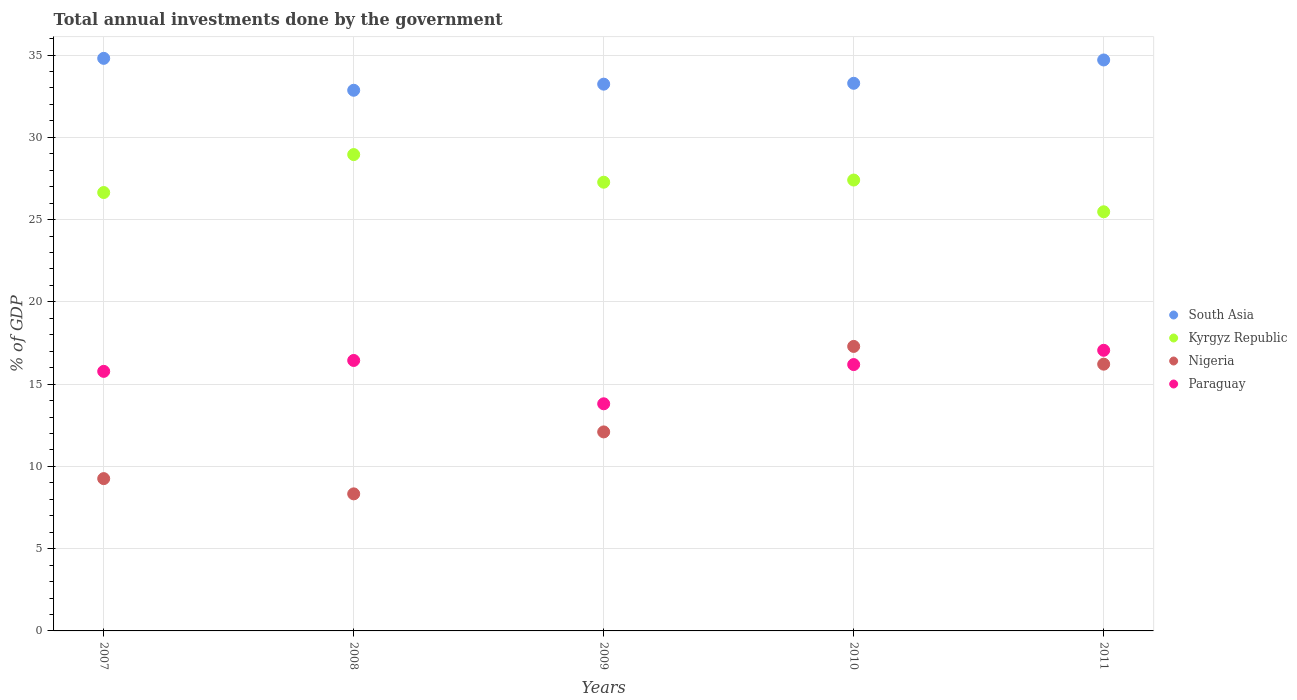How many different coloured dotlines are there?
Offer a terse response. 4. What is the total annual investments done by the government in Kyrgyz Republic in 2009?
Give a very brief answer. 27.27. Across all years, what is the maximum total annual investments done by the government in South Asia?
Provide a succinct answer. 34.8. Across all years, what is the minimum total annual investments done by the government in Paraguay?
Your response must be concise. 13.8. In which year was the total annual investments done by the government in Kyrgyz Republic maximum?
Your answer should be compact. 2008. In which year was the total annual investments done by the government in Nigeria minimum?
Offer a very short reply. 2008. What is the total total annual investments done by the government in Nigeria in the graph?
Your answer should be very brief. 63.18. What is the difference between the total annual investments done by the government in South Asia in 2009 and that in 2010?
Give a very brief answer. -0.05. What is the difference between the total annual investments done by the government in Nigeria in 2007 and the total annual investments done by the government in Kyrgyz Republic in 2009?
Offer a terse response. -18.01. What is the average total annual investments done by the government in Paraguay per year?
Offer a terse response. 15.85. In the year 2009, what is the difference between the total annual investments done by the government in South Asia and total annual investments done by the government in Nigeria?
Your answer should be very brief. 21.13. What is the ratio of the total annual investments done by the government in Kyrgyz Republic in 2008 to that in 2010?
Provide a succinct answer. 1.06. Is the total annual investments done by the government in South Asia in 2007 less than that in 2009?
Provide a short and direct response. No. Is the difference between the total annual investments done by the government in South Asia in 2007 and 2009 greater than the difference between the total annual investments done by the government in Nigeria in 2007 and 2009?
Ensure brevity in your answer.  Yes. What is the difference between the highest and the second highest total annual investments done by the government in South Asia?
Provide a short and direct response. 0.1. What is the difference between the highest and the lowest total annual investments done by the government in Nigeria?
Your answer should be compact. 8.96. In how many years, is the total annual investments done by the government in Paraguay greater than the average total annual investments done by the government in Paraguay taken over all years?
Offer a very short reply. 3. Is it the case that in every year, the sum of the total annual investments done by the government in Nigeria and total annual investments done by the government in Kyrgyz Republic  is greater than the total annual investments done by the government in Paraguay?
Provide a succinct answer. Yes. Does the total annual investments done by the government in South Asia monotonically increase over the years?
Ensure brevity in your answer.  No. How many dotlines are there?
Provide a short and direct response. 4. What is the difference between two consecutive major ticks on the Y-axis?
Make the answer very short. 5. Does the graph contain grids?
Offer a very short reply. Yes. How many legend labels are there?
Your response must be concise. 4. What is the title of the graph?
Your answer should be very brief. Total annual investments done by the government. What is the label or title of the X-axis?
Your answer should be compact. Years. What is the label or title of the Y-axis?
Offer a very short reply. % of GDP. What is the % of GDP of South Asia in 2007?
Offer a very short reply. 34.8. What is the % of GDP in Kyrgyz Republic in 2007?
Give a very brief answer. 26.64. What is the % of GDP of Nigeria in 2007?
Provide a short and direct response. 9.26. What is the % of GDP in Paraguay in 2007?
Provide a succinct answer. 15.77. What is the % of GDP in South Asia in 2008?
Provide a succinct answer. 32.86. What is the % of GDP of Kyrgyz Republic in 2008?
Make the answer very short. 28.95. What is the % of GDP in Nigeria in 2008?
Provide a short and direct response. 8.33. What is the % of GDP in Paraguay in 2008?
Your response must be concise. 16.44. What is the % of GDP in South Asia in 2009?
Provide a succinct answer. 33.23. What is the % of GDP of Kyrgyz Republic in 2009?
Keep it short and to the point. 27.27. What is the % of GDP in Nigeria in 2009?
Your answer should be very brief. 12.09. What is the % of GDP in Paraguay in 2009?
Keep it short and to the point. 13.8. What is the % of GDP of South Asia in 2010?
Provide a short and direct response. 33.28. What is the % of GDP in Kyrgyz Republic in 2010?
Offer a very short reply. 27.4. What is the % of GDP of Nigeria in 2010?
Your answer should be compact. 17.29. What is the % of GDP of Paraguay in 2010?
Give a very brief answer. 16.19. What is the % of GDP in South Asia in 2011?
Make the answer very short. 34.7. What is the % of GDP of Kyrgyz Republic in 2011?
Provide a short and direct response. 25.47. What is the % of GDP in Nigeria in 2011?
Provide a short and direct response. 16.21. What is the % of GDP of Paraguay in 2011?
Give a very brief answer. 17.05. Across all years, what is the maximum % of GDP of South Asia?
Your answer should be very brief. 34.8. Across all years, what is the maximum % of GDP in Kyrgyz Republic?
Provide a short and direct response. 28.95. Across all years, what is the maximum % of GDP of Nigeria?
Your answer should be compact. 17.29. Across all years, what is the maximum % of GDP in Paraguay?
Keep it short and to the point. 17.05. Across all years, what is the minimum % of GDP in South Asia?
Your answer should be compact. 32.86. Across all years, what is the minimum % of GDP of Kyrgyz Republic?
Your response must be concise. 25.47. Across all years, what is the minimum % of GDP of Nigeria?
Ensure brevity in your answer.  8.33. Across all years, what is the minimum % of GDP of Paraguay?
Offer a terse response. 13.8. What is the total % of GDP in South Asia in the graph?
Offer a very short reply. 168.87. What is the total % of GDP of Kyrgyz Republic in the graph?
Your answer should be very brief. 135.74. What is the total % of GDP in Nigeria in the graph?
Offer a terse response. 63.18. What is the total % of GDP in Paraguay in the graph?
Your answer should be compact. 79.26. What is the difference between the % of GDP in South Asia in 2007 and that in 2008?
Your response must be concise. 1.94. What is the difference between the % of GDP in Kyrgyz Republic in 2007 and that in 2008?
Give a very brief answer. -2.31. What is the difference between the % of GDP in Nigeria in 2007 and that in 2008?
Keep it short and to the point. 0.93. What is the difference between the % of GDP in Paraguay in 2007 and that in 2008?
Offer a very short reply. -0.66. What is the difference between the % of GDP of South Asia in 2007 and that in 2009?
Your answer should be very brief. 1.57. What is the difference between the % of GDP in Kyrgyz Republic in 2007 and that in 2009?
Make the answer very short. -0.63. What is the difference between the % of GDP in Nigeria in 2007 and that in 2009?
Your answer should be compact. -2.84. What is the difference between the % of GDP in Paraguay in 2007 and that in 2009?
Your response must be concise. 1.97. What is the difference between the % of GDP in South Asia in 2007 and that in 2010?
Offer a very short reply. 1.52. What is the difference between the % of GDP in Kyrgyz Republic in 2007 and that in 2010?
Give a very brief answer. -0.76. What is the difference between the % of GDP in Nigeria in 2007 and that in 2010?
Offer a terse response. -8.03. What is the difference between the % of GDP of Paraguay in 2007 and that in 2010?
Ensure brevity in your answer.  -0.41. What is the difference between the % of GDP in South Asia in 2007 and that in 2011?
Provide a short and direct response. 0.1. What is the difference between the % of GDP of Kyrgyz Republic in 2007 and that in 2011?
Give a very brief answer. 1.17. What is the difference between the % of GDP of Nigeria in 2007 and that in 2011?
Provide a succinct answer. -6.96. What is the difference between the % of GDP in Paraguay in 2007 and that in 2011?
Ensure brevity in your answer.  -1.28. What is the difference between the % of GDP of South Asia in 2008 and that in 2009?
Your answer should be compact. -0.37. What is the difference between the % of GDP in Kyrgyz Republic in 2008 and that in 2009?
Provide a succinct answer. 1.68. What is the difference between the % of GDP of Nigeria in 2008 and that in 2009?
Your answer should be compact. -3.76. What is the difference between the % of GDP of Paraguay in 2008 and that in 2009?
Offer a terse response. 2.63. What is the difference between the % of GDP of South Asia in 2008 and that in 2010?
Your response must be concise. -0.42. What is the difference between the % of GDP in Kyrgyz Republic in 2008 and that in 2010?
Your answer should be compact. 1.55. What is the difference between the % of GDP in Nigeria in 2008 and that in 2010?
Offer a terse response. -8.96. What is the difference between the % of GDP in Paraguay in 2008 and that in 2010?
Give a very brief answer. 0.25. What is the difference between the % of GDP of South Asia in 2008 and that in 2011?
Provide a succinct answer. -1.84. What is the difference between the % of GDP in Kyrgyz Republic in 2008 and that in 2011?
Offer a very short reply. 3.48. What is the difference between the % of GDP in Nigeria in 2008 and that in 2011?
Ensure brevity in your answer.  -7.88. What is the difference between the % of GDP of Paraguay in 2008 and that in 2011?
Your answer should be very brief. -0.62. What is the difference between the % of GDP of South Asia in 2009 and that in 2010?
Your answer should be very brief. -0.05. What is the difference between the % of GDP in Kyrgyz Republic in 2009 and that in 2010?
Give a very brief answer. -0.13. What is the difference between the % of GDP of Nigeria in 2009 and that in 2010?
Your answer should be very brief. -5.2. What is the difference between the % of GDP in Paraguay in 2009 and that in 2010?
Your answer should be compact. -2.38. What is the difference between the % of GDP of South Asia in 2009 and that in 2011?
Keep it short and to the point. -1.47. What is the difference between the % of GDP in Kyrgyz Republic in 2009 and that in 2011?
Offer a very short reply. 1.8. What is the difference between the % of GDP in Nigeria in 2009 and that in 2011?
Give a very brief answer. -4.12. What is the difference between the % of GDP in Paraguay in 2009 and that in 2011?
Offer a very short reply. -3.25. What is the difference between the % of GDP of South Asia in 2010 and that in 2011?
Offer a very short reply. -1.42. What is the difference between the % of GDP of Kyrgyz Republic in 2010 and that in 2011?
Your response must be concise. 1.93. What is the difference between the % of GDP in Nigeria in 2010 and that in 2011?
Your response must be concise. 1.08. What is the difference between the % of GDP of Paraguay in 2010 and that in 2011?
Your response must be concise. -0.87. What is the difference between the % of GDP in South Asia in 2007 and the % of GDP in Kyrgyz Republic in 2008?
Your answer should be compact. 5.85. What is the difference between the % of GDP of South Asia in 2007 and the % of GDP of Nigeria in 2008?
Your answer should be compact. 26.47. What is the difference between the % of GDP of South Asia in 2007 and the % of GDP of Paraguay in 2008?
Offer a very short reply. 18.36. What is the difference between the % of GDP of Kyrgyz Republic in 2007 and the % of GDP of Nigeria in 2008?
Your answer should be compact. 18.31. What is the difference between the % of GDP of Kyrgyz Republic in 2007 and the % of GDP of Paraguay in 2008?
Keep it short and to the point. 10.21. What is the difference between the % of GDP of Nigeria in 2007 and the % of GDP of Paraguay in 2008?
Keep it short and to the point. -7.18. What is the difference between the % of GDP in South Asia in 2007 and the % of GDP in Kyrgyz Republic in 2009?
Keep it short and to the point. 7.53. What is the difference between the % of GDP in South Asia in 2007 and the % of GDP in Nigeria in 2009?
Provide a short and direct response. 22.7. What is the difference between the % of GDP of South Asia in 2007 and the % of GDP of Paraguay in 2009?
Your answer should be compact. 20.99. What is the difference between the % of GDP of Kyrgyz Republic in 2007 and the % of GDP of Nigeria in 2009?
Your answer should be very brief. 14.55. What is the difference between the % of GDP of Kyrgyz Republic in 2007 and the % of GDP of Paraguay in 2009?
Make the answer very short. 12.84. What is the difference between the % of GDP of Nigeria in 2007 and the % of GDP of Paraguay in 2009?
Keep it short and to the point. -4.55. What is the difference between the % of GDP in South Asia in 2007 and the % of GDP in Kyrgyz Republic in 2010?
Your response must be concise. 7.4. What is the difference between the % of GDP in South Asia in 2007 and the % of GDP in Nigeria in 2010?
Offer a terse response. 17.51. What is the difference between the % of GDP in South Asia in 2007 and the % of GDP in Paraguay in 2010?
Give a very brief answer. 18.61. What is the difference between the % of GDP in Kyrgyz Republic in 2007 and the % of GDP in Nigeria in 2010?
Your answer should be compact. 9.35. What is the difference between the % of GDP of Kyrgyz Republic in 2007 and the % of GDP of Paraguay in 2010?
Provide a succinct answer. 10.46. What is the difference between the % of GDP in Nigeria in 2007 and the % of GDP in Paraguay in 2010?
Make the answer very short. -6.93. What is the difference between the % of GDP in South Asia in 2007 and the % of GDP in Kyrgyz Republic in 2011?
Your response must be concise. 9.32. What is the difference between the % of GDP of South Asia in 2007 and the % of GDP of Nigeria in 2011?
Your response must be concise. 18.59. What is the difference between the % of GDP in South Asia in 2007 and the % of GDP in Paraguay in 2011?
Make the answer very short. 17.74. What is the difference between the % of GDP of Kyrgyz Republic in 2007 and the % of GDP of Nigeria in 2011?
Your response must be concise. 10.43. What is the difference between the % of GDP of Kyrgyz Republic in 2007 and the % of GDP of Paraguay in 2011?
Provide a succinct answer. 9.59. What is the difference between the % of GDP in Nigeria in 2007 and the % of GDP in Paraguay in 2011?
Offer a very short reply. -7.8. What is the difference between the % of GDP in South Asia in 2008 and the % of GDP in Kyrgyz Republic in 2009?
Offer a very short reply. 5.59. What is the difference between the % of GDP of South Asia in 2008 and the % of GDP of Nigeria in 2009?
Make the answer very short. 20.76. What is the difference between the % of GDP of South Asia in 2008 and the % of GDP of Paraguay in 2009?
Your response must be concise. 19.05. What is the difference between the % of GDP in Kyrgyz Republic in 2008 and the % of GDP in Nigeria in 2009?
Provide a succinct answer. 16.85. What is the difference between the % of GDP of Kyrgyz Republic in 2008 and the % of GDP of Paraguay in 2009?
Your response must be concise. 15.14. What is the difference between the % of GDP in Nigeria in 2008 and the % of GDP in Paraguay in 2009?
Your answer should be compact. -5.47. What is the difference between the % of GDP of South Asia in 2008 and the % of GDP of Kyrgyz Republic in 2010?
Offer a very short reply. 5.46. What is the difference between the % of GDP of South Asia in 2008 and the % of GDP of Nigeria in 2010?
Give a very brief answer. 15.57. What is the difference between the % of GDP of South Asia in 2008 and the % of GDP of Paraguay in 2010?
Keep it short and to the point. 16.67. What is the difference between the % of GDP in Kyrgyz Republic in 2008 and the % of GDP in Nigeria in 2010?
Give a very brief answer. 11.66. What is the difference between the % of GDP of Kyrgyz Republic in 2008 and the % of GDP of Paraguay in 2010?
Keep it short and to the point. 12.76. What is the difference between the % of GDP in Nigeria in 2008 and the % of GDP in Paraguay in 2010?
Your answer should be compact. -7.86. What is the difference between the % of GDP of South Asia in 2008 and the % of GDP of Kyrgyz Republic in 2011?
Keep it short and to the point. 7.38. What is the difference between the % of GDP of South Asia in 2008 and the % of GDP of Nigeria in 2011?
Your answer should be very brief. 16.65. What is the difference between the % of GDP of South Asia in 2008 and the % of GDP of Paraguay in 2011?
Offer a very short reply. 15.8. What is the difference between the % of GDP in Kyrgyz Republic in 2008 and the % of GDP in Nigeria in 2011?
Your answer should be very brief. 12.74. What is the difference between the % of GDP in Kyrgyz Republic in 2008 and the % of GDP in Paraguay in 2011?
Your answer should be very brief. 11.89. What is the difference between the % of GDP in Nigeria in 2008 and the % of GDP in Paraguay in 2011?
Your response must be concise. -8.72. What is the difference between the % of GDP in South Asia in 2009 and the % of GDP in Kyrgyz Republic in 2010?
Your response must be concise. 5.83. What is the difference between the % of GDP in South Asia in 2009 and the % of GDP in Nigeria in 2010?
Provide a succinct answer. 15.94. What is the difference between the % of GDP of South Asia in 2009 and the % of GDP of Paraguay in 2010?
Ensure brevity in your answer.  17.04. What is the difference between the % of GDP of Kyrgyz Republic in 2009 and the % of GDP of Nigeria in 2010?
Offer a terse response. 9.98. What is the difference between the % of GDP in Kyrgyz Republic in 2009 and the % of GDP in Paraguay in 2010?
Your answer should be very brief. 11.08. What is the difference between the % of GDP in Nigeria in 2009 and the % of GDP in Paraguay in 2010?
Give a very brief answer. -4.09. What is the difference between the % of GDP of South Asia in 2009 and the % of GDP of Kyrgyz Republic in 2011?
Your response must be concise. 7.76. What is the difference between the % of GDP in South Asia in 2009 and the % of GDP in Nigeria in 2011?
Offer a very short reply. 17.02. What is the difference between the % of GDP of South Asia in 2009 and the % of GDP of Paraguay in 2011?
Keep it short and to the point. 16.17. What is the difference between the % of GDP in Kyrgyz Republic in 2009 and the % of GDP in Nigeria in 2011?
Keep it short and to the point. 11.06. What is the difference between the % of GDP of Kyrgyz Republic in 2009 and the % of GDP of Paraguay in 2011?
Give a very brief answer. 10.22. What is the difference between the % of GDP of Nigeria in 2009 and the % of GDP of Paraguay in 2011?
Your answer should be very brief. -4.96. What is the difference between the % of GDP of South Asia in 2010 and the % of GDP of Kyrgyz Republic in 2011?
Offer a very short reply. 7.81. What is the difference between the % of GDP in South Asia in 2010 and the % of GDP in Nigeria in 2011?
Provide a succinct answer. 17.07. What is the difference between the % of GDP in South Asia in 2010 and the % of GDP in Paraguay in 2011?
Provide a short and direct response. 16.23. What is the difference between the % of GDP in Kyrgyz Republic in 2010 and the % of GDP in Nigeria in 2011?
Keep it short and to the point. 11.19. What is the difference between the % of GDP of Kyrgyz Republic in 2010 and the % of GDP of Paraguay in 2011?
Ensure brevity in your answer.  10.35. What is the difference between the % of GDP in Nigeria in 2010 and the % of GDP in Paraguay in 2011?
Make the answer very short. 0.24. What is the average % of GDP of South Asia per year?
Your answer should be compact. 33.77. What is the average % of GDP of Kyrgyz Republic per year?
Offer a terse response. 27.15. What is the average % of GDP of Nigeria per year?
Make the answer very short. 12.64. What is the average % of GDP of Paraguay per year?
Keep it short and to the point. 15.85. In the year 2007, what is the difference between the % of GDP of South Asia and % of GDP of Kyrgyz Republic?
Provide a short and direct response. 8.15. In the year 2007, what is the difference between the % of GDP of South Asia and % of GDP of Nigeria?
Provide a succinct answer. 25.54. In the year 2007, what is the difference between the % of GDP of South Asia and % of GDP of Paraguay?
Provide a succinct answer. 19.02. In the year 2007, what is the difference between the % of GDP in Kyrgyz Republic and % of GDP in Nigeria?
Offer a terse response. 17.39. In the year 2007, what is the difference between the % of GDP in Kyrgyz Republic and % of GDP in Paraguay?
Provide a succinct answer. 10.87. In the year 2007, what is the difference between the % of GDP in Nigeria and % of GDP in Paraguay?
Offer a very short reply. -6.52. In the year 2008, what is the difference between the % of GDP of South Asia and % of GDP of Kyrgyz Republic?
Your answer should be very brief. 3.91. In the year 2008, what is the difference between the % of GDP of South Asia and % of GDP of Nigeria?
Ensure brevity in your answer.  24.53. In the year 2008, what is the difference between the % of GDP of South Asia and % of GDP of Paraguay?
Offer a terse response. 16.42. In the year 2008, what is the difference between the % of GDP in Kyrgyz Republic and % of GDP in Nigeria?
Offer a very short reply. 20.62. In the year 2008, what is the difference between the % of GDP in Kyrgyz Republic and % of GDP in Paraguay?
Provide a succinct answer. 12.51. In the year 2008, what is the difference between the % of GDP of Nigeria and % of GDP of Paraguay?
Provide a succinct answer. -8.11. In the year 2009, what is the difference between the % of GDP of South Asia and % of GDP of Kyrgyz Republic?
Your answer should be compact. 5.96. In the year 2009, what is the difference between the % of GDP of South Asia and % of GDP of Nigeria?
Offer a terse response. 21.13. In the year 2009, what is the difference between the % of GDP in South Asia and % of GDP in Paraguay?
Your answer should be very brief. 19.42. In the year 2009, what is the difference between the % of GDP of Kyrgyz Republic and % of GDP of Nigeria?
Make the answer very short. 15.18. In the year 2009, what is the difference between the % of GDP of Kyrgyz Republic and % of GDP of Paraguay?
Your answer should be compact. 13.47. In the year 2009, what is the difference between the % of GDP in Nigeria and % of GDP in Paraguay?
Your response must be concise. -1.71. In the year 2010, what is the difference between the % of GDP in South Asia and % of GDP in Kyrgyz Republic?
Your response must be concise. 5.88. In the year 2010, what is the difference between the % of GDP of South Asia and % of GDP of Nigeria?
Offer a very short reply. 15.99. In the year 2010, what is the difference between the % of GDP of South Asia and % of GDP of Paraguay?
Keep it short and to the point. 17.09. In the year 2010, what is the difference between the % of GDP in Kyrgyz Republic and % of GDP in Nigeria?
Provide a short and direct response. 10.11. In the year 2010, what is the difference between the % of GDP of Kyrgyz Republic and % of GDP of Paraguay?
Provide a succinct answer. 11.21. In the year 2010, what is the difference between the % of GDP in Nigeria and % of GDP in Paraguay?
Your answer should be very brief. 1.1. In the year 2011, what is the difference between the % of GDP in South Asia and % of GDP in Kyrgyz Republic?
Your response must be concise. 9.23. In the year 2011, what is the difference between the % of GDP in South Asia and % of GDP in Nigeria?
Make the answer very short. 18.49. In the year 2011, what is the difference between the % of GDP in South Asia and % of GDP in Paraguay?
Give a very brief answer. 17.64. In the year 2011, what is the difference between the % of GDP in Kyrgyz Republic and % of GDP in Nigeria?
Offer a terse response. 9.26. In the year 2011, what is the difference between the % of GDP in Kyrgyz Republic and % of GDP in Paraguay?
Provide a short and direct response. 8.42. In the year 2011, what is the difference between the % of GDP of Nigeria and % of GDP of Paraguay?
Your answer should be compact. -0.84. What is the ratio of the % of GDP of South Asia in 2007 to that in 2008?
Provide a succinct answer. 1.06. What is the ratio of the % of GDP of Kyrgyz Republic in 2007 to that in 2008?
Provide a succinct answer. 0.92. What is the ratio of the % of GDP of Nigeria in 2007 to that in 2008?
Your answer should be compact. 1.11. What is the ratio of the % of GDP of Paraguay in 2007 to that in 2008?
Offer a terse response. 0.96. What is the ratio of the % of GDP in South Asia in 2007 to that in 2009?
Offer a very short reply. 1.05. What is the ratio of the % of GDP of Kyrgyz Republic in 2007 to that in 2009?
Offer a very short reply. 0.98. What is the ratio of the % of GDP of Nigeria in 2007 to that in 2009?
Provide a short and direct response. 0.77. What is the ratio of the % of GDP of Paraguay in 2007 to that in 2009?
Your answer should be compact. 1.14. What is the ratio of the % of GDP of South Asia in 2007 to that in 2010?
Give a very brief answer. 1.05. What is the ratio of the % of GDP in Kyrgyz Republic in 2007 to that in 2010?
Your answer should be very brief. 0.97. What is the ratio of the % of GDP in Nigeria in 2007 to that in 2010?
Offer a terse response. 0.54. What is the ratio of the % of GDP of Paraguay in 2007 to that in 2010?
Your response must be concise. 0.97. What is the ratio of the % of GDP in Kyrgyz Republic in 2007 to that in 2011?
Keep it short and to the point. 1.05. What is the ratio of the % of GDP in Nigeria in 2007 to that in 2011?
Your response must be concise. 0.57. What is the ratio of the % of GDP in Paraguay in 2007 to that in 2011?
Give a very brief answer. 0.92. What is the ratio of the % of GDP in South Asia in 2008 to that in 2009?
Offer a very short reply. 0.99. What is the ratio of the % of GDP in Kyrgyz Republic in 2008 to that in 2009?
Ensure brevity in your answer.  1.06. What is the ratio of the % of GDP of Nigeria in 2008 to that in 2009?
Offer a very short reply. 0.69. What is the ratio of the % of GDP in Paraguay in 2008 to that in 2009?
Give a very brief answer. 1.19. What is the ratio of the % of GDP of South Asia in 2008 to that in 2010?
Ensure brevity in your answer.  0.99. What is the ratio of the % of GDP in Kyrgyz Republic in 2008 to that in 2010?
Provide a short and direct response. 1.06. What is the ratio of the % of GDP in Nigeria in 2008 to that in 2010?
Your answer should be compact. 0.48. What is the ratio of the % of GDP of Paraguay in 2008 to that in 2010?
Ensure brevity in your answer.  1.02. What is the ratio of the % of GDP of South Asia in 2008 to that in 2011?
Offer a terse response. 0.95. What is the ratio of the % of GDP of Kyrgyz Republic in 2008 to that in 2011?
Give a very brief answer. 1.14. What is the ratio of the % of GDP in Nigeria in 2008 to that in 2011?
Provide a succinct answer. 0.51. What is the ratio of the % of GDP of Paraguay in 2008 to that in 2011?
Offer a terse response. 0.96. What is the ratio of the % of GDP of Kyrgyz Republic in 2009 to that in 2010?
Ensure brevity in your answer.  1. What is the ratio of the % of GDP of Nigeria in 2009 to that in 2010?
Make the answer very short. 0.7. What is the ratio of the % of GDP of Paraguay in 2009 to that in 2010?
Offer a very short reply. 0.85. What is the ratio of the % of GDP of South Asia in 2009 to that in 2011?
Your response must be concise. 0.96. What is the ratio of the % of GDP in Kyrgyz Republic in 2009 to that in 2011?
Offer a very short reply. 1.07. What is the ratio of the % of GDP in Nigeria in 2009 to that in 2011?
Make the answer very short. 0.75. What is the ratio of the % of GDP in Paraguay in 2009 to that in 2011?
Give a very brief answer. 0.81. What is the ratio of the % of GDP of South Asia in 2010 to that in 2011?
Provide a succinct answer. 0.96. What is the ratio of the % of GDP in Kyrgyz Republic in 2010 to that in 2011?
Provide a succinct answer. 1.08. What is the ratio of the % of GDP of Nigeria in 2010 to that in 2011?
Make the answer very short. 1.07. What is the ratio of the % of GDP in Paraguay in 2010 to that in 2011?
Your answer should be compact. 0.95. What is the difference between the highest and the second highest % of GDP in South Asia?
Your answer should be very brief. 0.1. What is the difference between the highest and the second highest % of GDP in Kyrgyz Republic?
Provide a short and direct response. 1.55. What is the difference between the highest and the second highest % of GDP in Nigeria?
Provide a short and direct response. 1.08. What is the difference between the highest and the second highest % of GDP in Paraguay?
Offer a very short reply. 0.62. What is the difference between the highest and the lowest % of GDP in South Asia?
Keep it short and to the point. 1.94. What is the difference between the highest and the lowest % of GDP in Kyrgyz Republic?
Offer a very short reply. 3.48. What is the difference between the highest and the lowest % of GDP of Nigeria?
Offer a very short reply. 8.96. What is the difference between the highest and the lowest % of GDP of Paraguay?
Give a very brief answer. 3.25. 